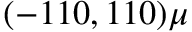Convert formula to latex. <formula><loc_0><loc_0><loc_500><loc_500>( - 1 1 0 , 1 1 0 ) \mu</formula> 